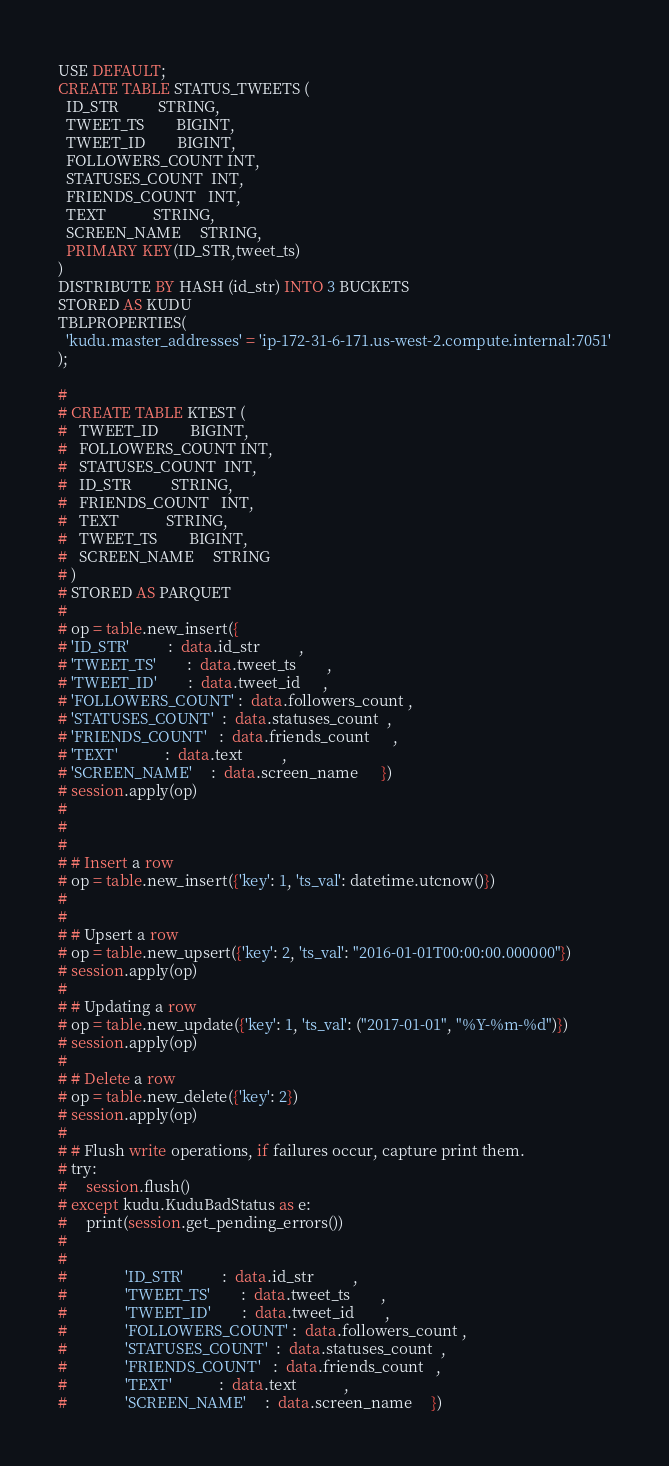Convert code to text. <code><loc_0><loc_0><loc_500><loc_500><_SQL_>
USE DEFAULT;
CREATE TABLE STATUS_TWEETS (
  ID_STR          STRING,
  TWEET_TS        BIGINT,
  TWEET_ID        BIGINT,
  FOLLOWERS_COUNT INT,
  STATUSES_COUNT  INT,
  FRIENDS_COUNT   INT,
  TEXT            STRING,
  SCREEN_NAME     STRING,
  PRIMARY KEY(ID_STR,tweet_ts)
)
DISTRIBUTE BY HASH (id_str) INTO 3 BUCKETS
STORED AS KUDU
TBLPROPERTIES(
  'kudu.master_addresses' = 'ip-172-31-6-171.us-west-2.compute.internal:7051'
);

# 
# CREATE TABLE KTEST (
#   TWEET_ID        BIGINT,
#   FOLLOWERS_COUNT INT,
#   STATUSES_COUNT  INT,
#   ID_STR          STRING,
#   FRIENDS_COUNT   INT,
#   TEXT            STRING,
#   TWEET_TS        BIGINT,
#   SCREEN_NAME     STRING
# )
# STORED AS PARQUET
# 
# op = table.new_insert({
# 'ID_STR'          :  data.id_str          ,
# 'TWEET_TS'        :  data.tweet_ts        ,
# 'TWEET_ID'        :  data.tweet_id	  ,
# 'FOLLOWERS_COUNT' :  data.followers_count ,
# 'STATUSES_COUNT'  :  data.statuses_count  ,	  
# 'FRIENDS_COUNT'   :  data.friends_count	  ,
# 'TEXT'            :  data.text		  ,
# 'SCREEN_NAME'     :  data.screen_name	  })
# session.apply(op)
# 
# 
# 
# # Insert a row
# op = table.new_insert({'key': 1, 'ts_val': datetime.utcnow()})
# 
# 
# # Upsert a row
# op = table.new_upsert({'key': 2, 'ts_val': "2016-01-01T00:00:00.000000"})
# session.apply(op)
# 
# # Updating a row
# op = table.new_update({'key': 1, 'ts_val': ("2017-01-01", "%Y-%m-%d")})
# session.apply(op)
# 
# # Delete a row
# op = table.new_delete({'key': 2})
# session.apply(op)
# 
# # Flush write operations, if failures occur, capture print them.
# try:
#     session.flush()
# except kudu.KuduBadStatus as e:
#     print(session.get_pending_errors())
# 
# 
#               'ID_STR'          :  data.id_str          ,
#               'TWEET_TS'        :  data.tweet_ts        ,
#               'TWEET_ID'        :  data.tweet_id        ,
#               'FOLLOWERS_COUNT' :  data.followers_count ,
#               'STATUSES_COUNT'  :  data.statuses_count  ,
#               'FRIENDS_COUNT'   :  data.friends_count   ,
#               'TEXT'            :  data.text            ,
#               'SCREEN_NAME'     :  data.screen_name     })
</code> 